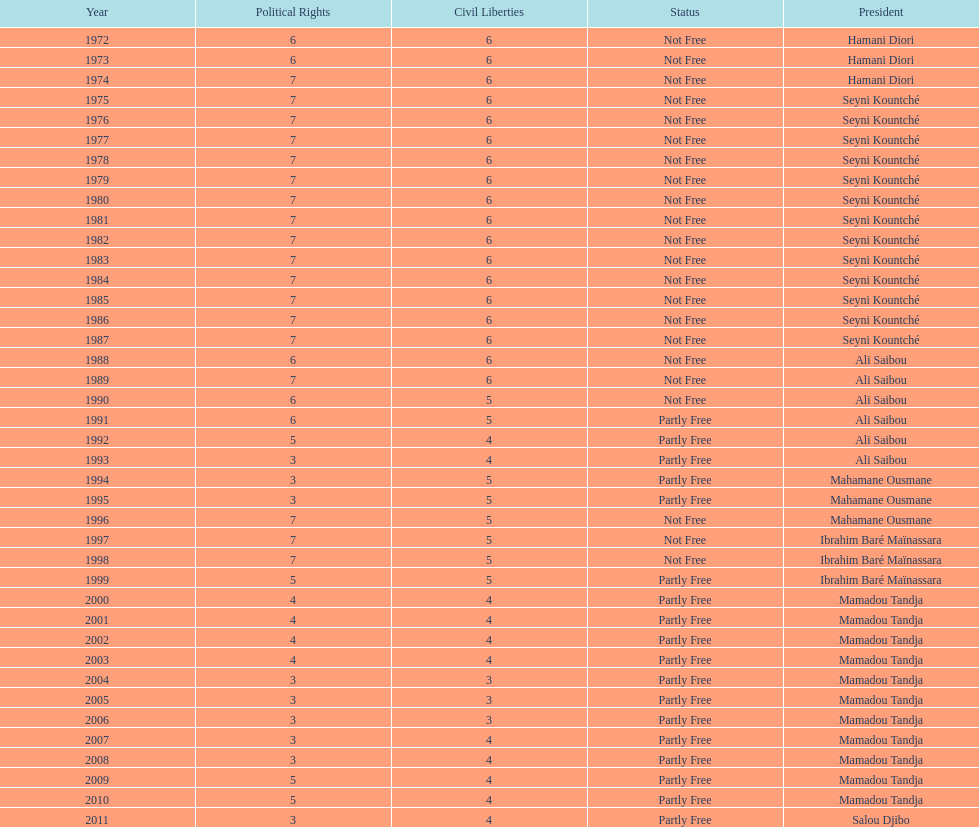How many occurrences involved the political rights being cited as seven? 18. 